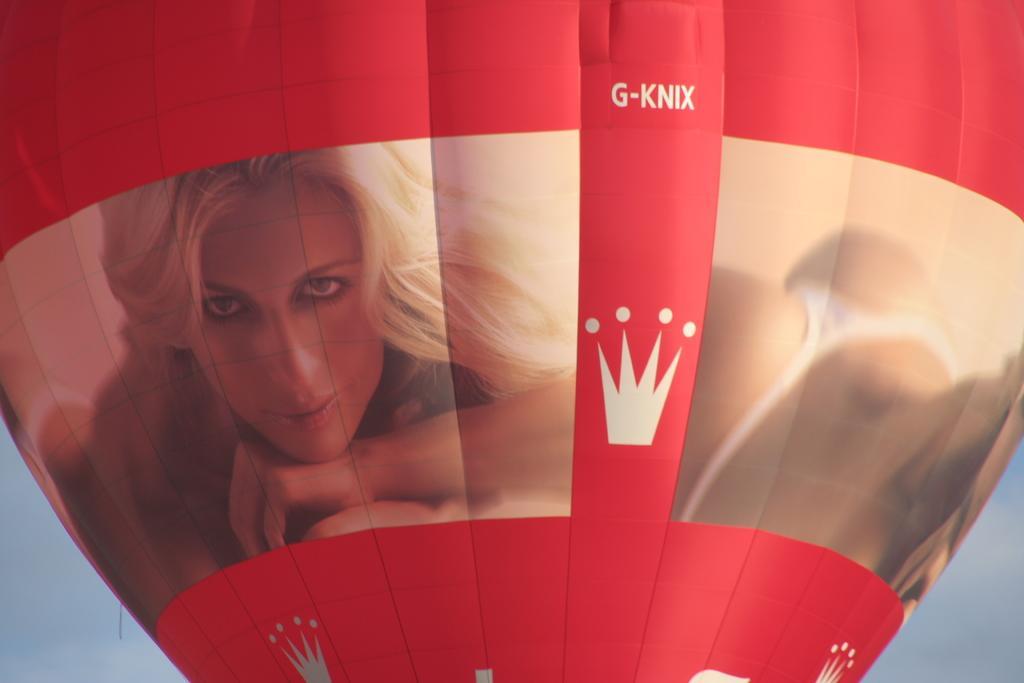Describe this image in one or two sentences. In this picture we can see a parachute with a photo of a girl smiling on it and in the background we can see the sky. 